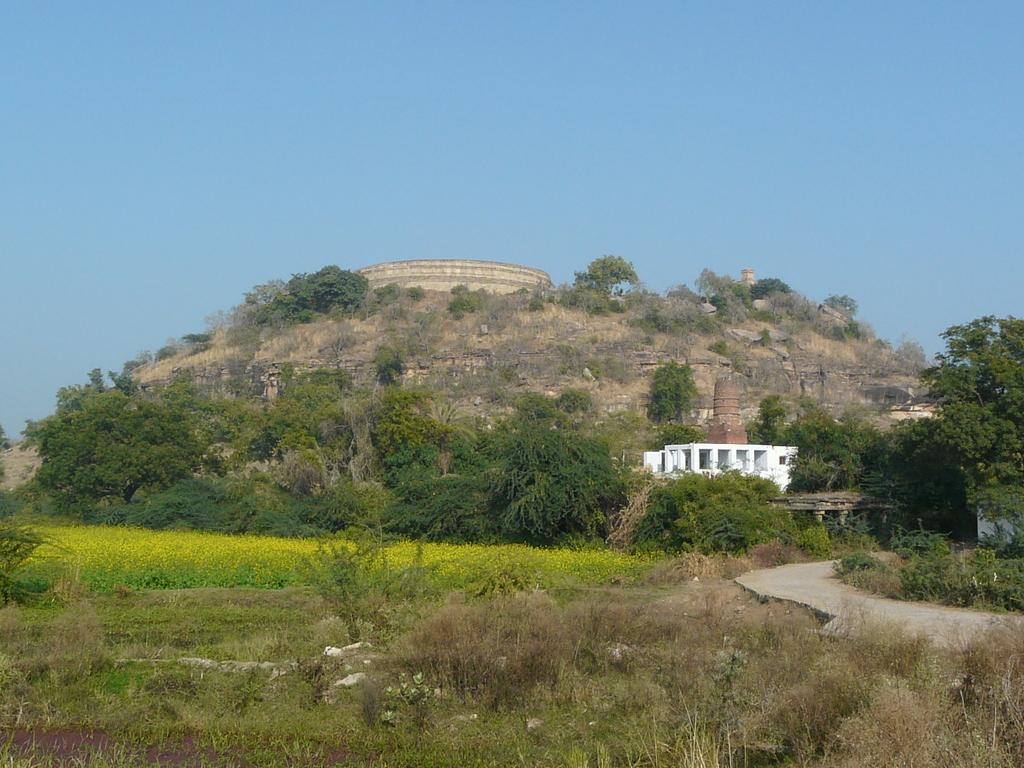Can you describe this image briefly? In this image we can see a fort on the mountains and there is a white color building, there are some trees, plants and grass, in the background we can see the sky. 